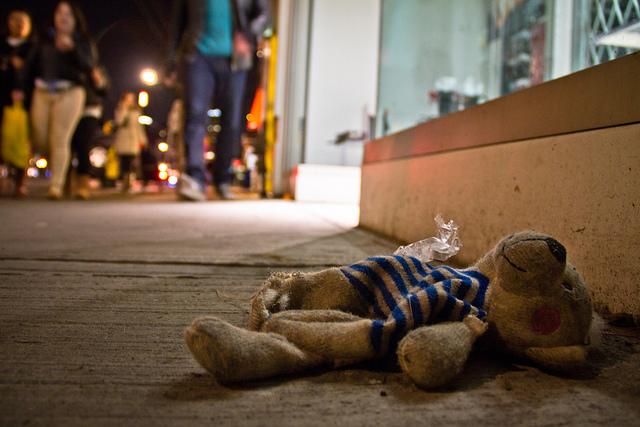What is the bear looking into?
Be succinct. Sky. Do you see any vehicles?
Concise answer only. No. Which animals are they?
Quick response, please. Bear. What is interesting about this?
Quick response, please. It's artistic. Is this an old or new teddy bear?
Answer briefly. Old. What color is the carpet?
Quick response, please. Brown. Are the bears seated or standing?
Write a very short answer. Seated. Is the bear seriously injured?
Keep it brief. Yes. Is it daytime?
Short answer required. No. What kind of bear is this?
Concise answer only. Teddy. What type of animal is laying on the ground?
Concise answer only. Bear. What color are the stripes on the teddy bear?
Give a very brief answer. Blue. Is the bear laying on carpet?
Write a very short answer. Yes. What are the bears sitting on?
Answer briefly. Ground. Is this picture show Paddington Bear?
Keep it brief. No. Is there a toy parrot on the windowsill?
Write a very short answer. No. What is the blue line a part of?
Keep it brief. Shirt. How many bears?
Short answer required. 1. 